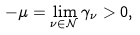Convert formula to latex. <formula><loc_0><loc_0><loc_500><loc_500>- \mu = \lim _ { \nu \in \mathcal { N } } \gamma _ { \nu } > 0 ,</formula> 